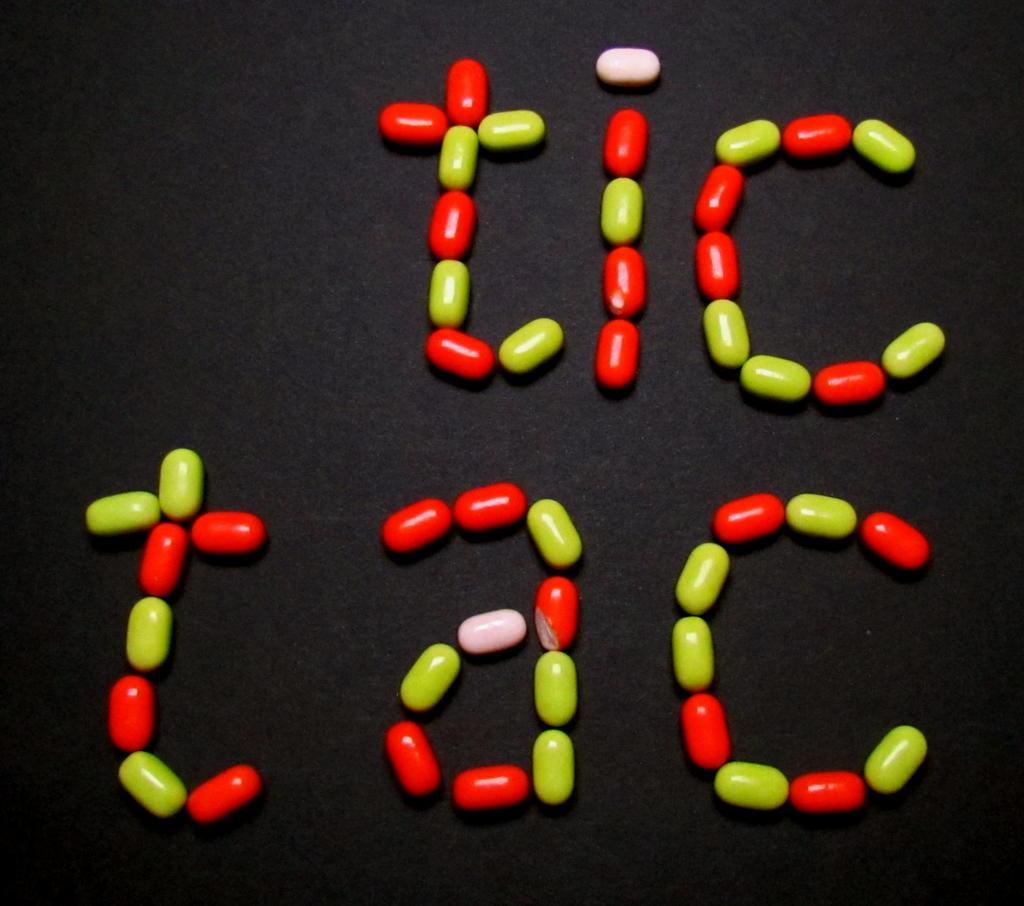What type of food is present in the image? There is candy in the image. What colors can be seen on the candy? The candy has green, red, and pale pink colors. What is the color of the surface on which the candy is placed? The candy is placed on a black surface. What type of honey is being used to power the apparatus in the image? There is no honey or apparatus present in the image; it only features candy on a black surface. 